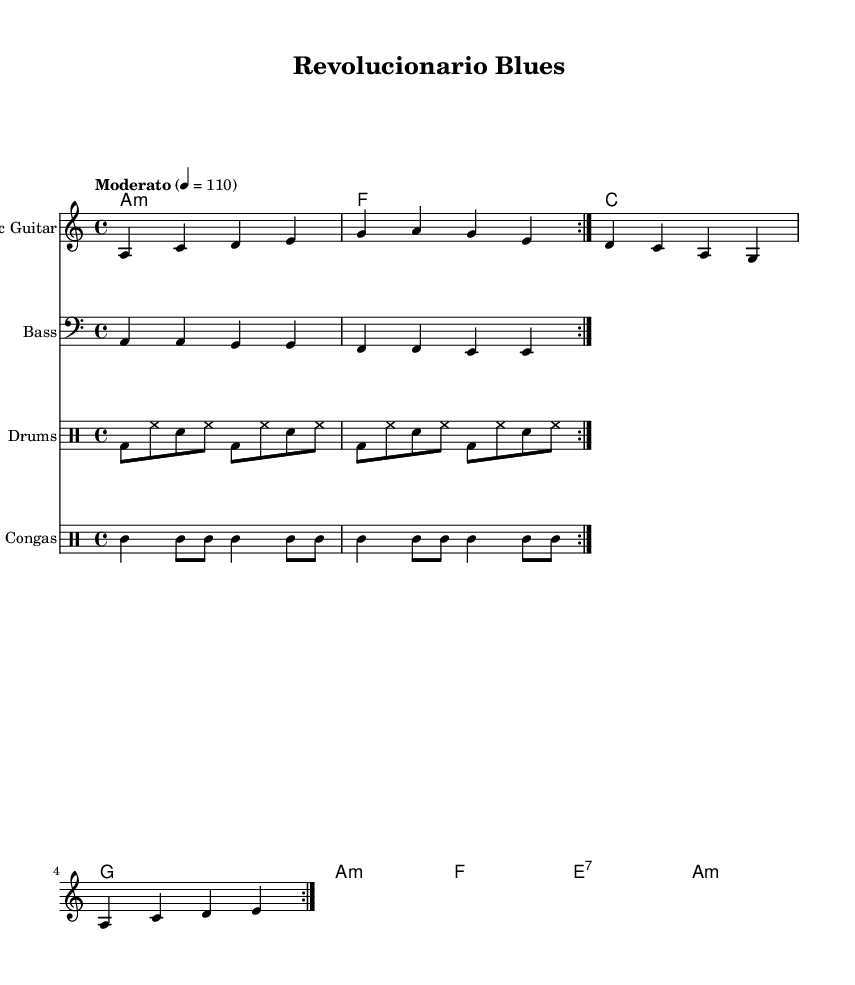What is the key signature of this music? The key signature is indicated by the notation at the beginning of the score. In this case, the music is in A minor, which has no sharps or flats.
Answer: A minor What is the time signature of this composition? The time signature is shown just after the key signature in the score setup. Here, it is 4/4, indicating four beats per measure.
Answer: 4/4 What is the tempo marking for the piece? The tempo marking appears at the beginning of the score, specifying the speed of the music. It states "Moderato" at a quarter note = 110 beats per minute.
Answer: Moderato 4 = 110 How many measures are in the electric guitar part? To find the number of measures, we look at the repeated section indicated by "repeat volta" and count the number of distinct measures. There are 4 measures in the section, repeated twice.
Answer: 4 Which instruments are featured in this piece? The instruments are listed in the score and include Electric Guitar, Bass, Drums, and Congas. Each has its notation staff in the score.
Answer: Electric Guitar, Bass, Drums, Congas What chord is played at the end of the first section? By examining the chord names at the bottom of the score, the last chord in the first section, after the repeat, is A minor.
Answer: A minor What is the rhythmic role of the congas in this piece? The congas are notated with their own rhythm staff, and we can see they play a syncopated pattern that complements the drum rhythm, enhancing the Latin feel of the piece.
Answer: Syncopated pattern 